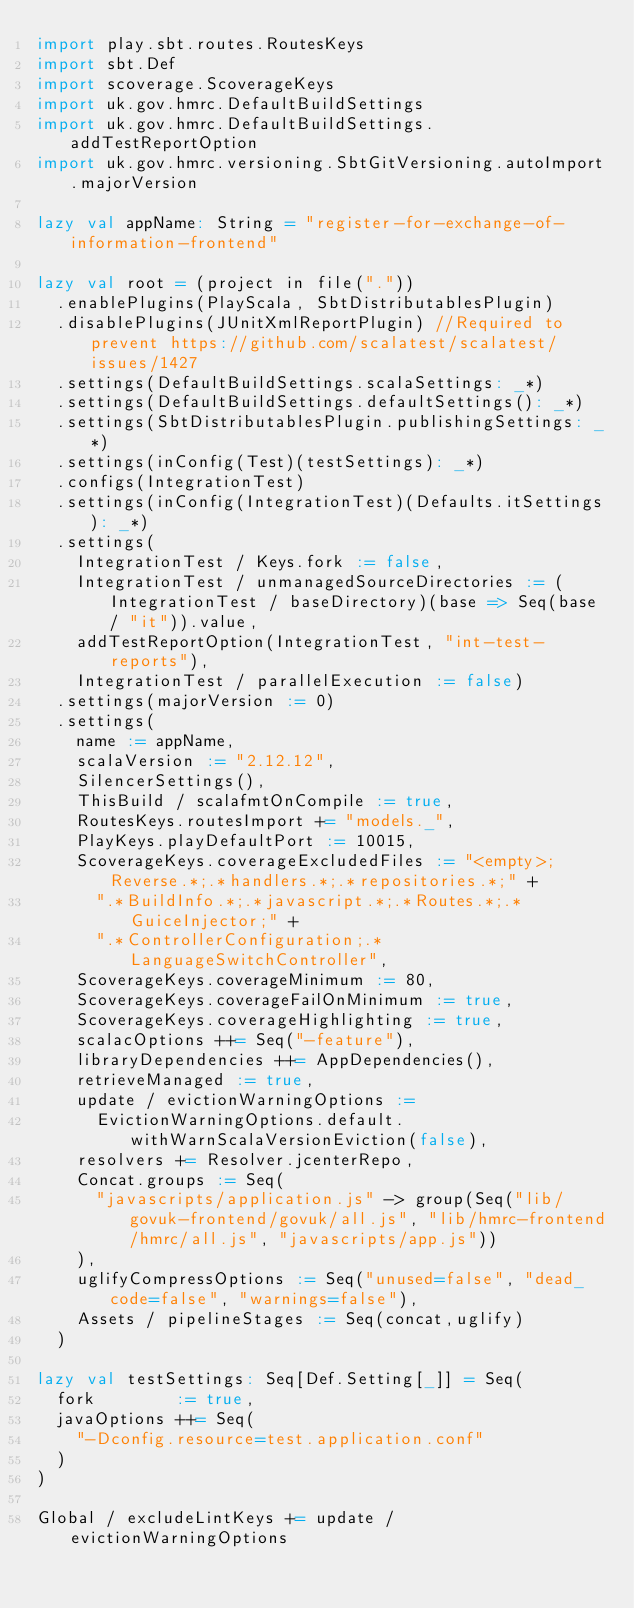<code> <loc_0><loc_0><loc_500><loc_500><_Scala_>import play.sbt.routes.RoutesKeys
import sbt.Def
import scoverage.ScoverageKeys
import uk.gov.hmrc.DefaultBuildSettings
import uk.gov.hmrc.DefaultBuildSettings.addTestReportOption
import uk.gov.hmrc.versioning.SbtGitVersioning.autoImport.majorVersion

lazy val appName: String = "register-for-exchange-of-information-frontend"

lazy val root = (project in file("."))
  .enablePlugins(PlayScala, SbtDistributablesPlugin)
  .disablePlugins(JUnitXmlReportPlugin) //Required to prevent https://github.com/scalatest/scalatest/issues/1427
  .settings(DefaultBuildSettings.scalaSettings: _*)
  .settings(DefaultBuildSettings.defaultSettings(): _*)
  .settings(SbtDistributablesPlugin.publishingSettings: _*)
  .settings(inConfig(Test)(testSettings): _*)
  .configs(IntegrationTest)
  .settings(inConfig(IntegrationTest)(Defaults.itSettings): _*)
  .settings(
    IntegrationTest / Keys.fork := false,
    IntegrationTest / unmanagedSourceDirectories := (IntegrationTest / baseDirectory)(base => Seq(base / "it")).value,
    addTestReportOption(IntegrationTest, "int-test-reports"),
    IntegrationTest / parallelExecution := false)
  .settings(majorVersion := 0)
  .settings(
    name := appName,
    scalaVersion := "2.12.12",
    SilencerSettings(),
    ThisBuild / scalafmtOnCompile := true,
    RoutesKeys.routesImport += "models._",
    PlayKeys.playDefaultPort := 10015,
    ScoverageKeys.coverageExcludedFiles := "<empty>;Reverse.*;.*handlers.*;.*repositories.*;" +
      ".*BuildInfo.*;.*javascript.*;.*Routes.*;.*GuiceInjector;" +
      ".*ControllerConfiguration;.*LanguageSwitchController",
    ScoverageKeys.coverageMinimum := 80,
    ScoverageKeys.coverageFailOnMinimum := true,
    ScoverageKeys.coverageHighlighting := true,
    scalacOptions ++= Seq("-feature"),
    libraryDependencies ++= AppDependencies(),
    retrieveManaged := true,
    update / evictionWarningOptions :=
      EvictionWarningOptions.default.withWarnScalaVersionEviction(false),
    resolvers += Resolver.jcenterRepo,
    Concat.groups := Seq(
      "javascripts/application.js" -> group(Seq("lib/govuk-frontend/govuk/all.js", "lib/hmrc-frontend/hmrc/all.js", "javascripts/app.js"))
    ),
    uglifyCompressOptions := Seq("unused=false", "dead_code=false", "warnings=false"),
    Assets / pipelineStages := Seq(concat,uglify)
  )

lazy val testSettings: Seq[Def.Setting[_]] = Seq(
  fork        := true,
  javaOptions ++= Seq(
    "-Dconfig.resource=test.application.conf"
  )
)

Global / excludeLintKeys += update / evictionWarningOptions

</code> 